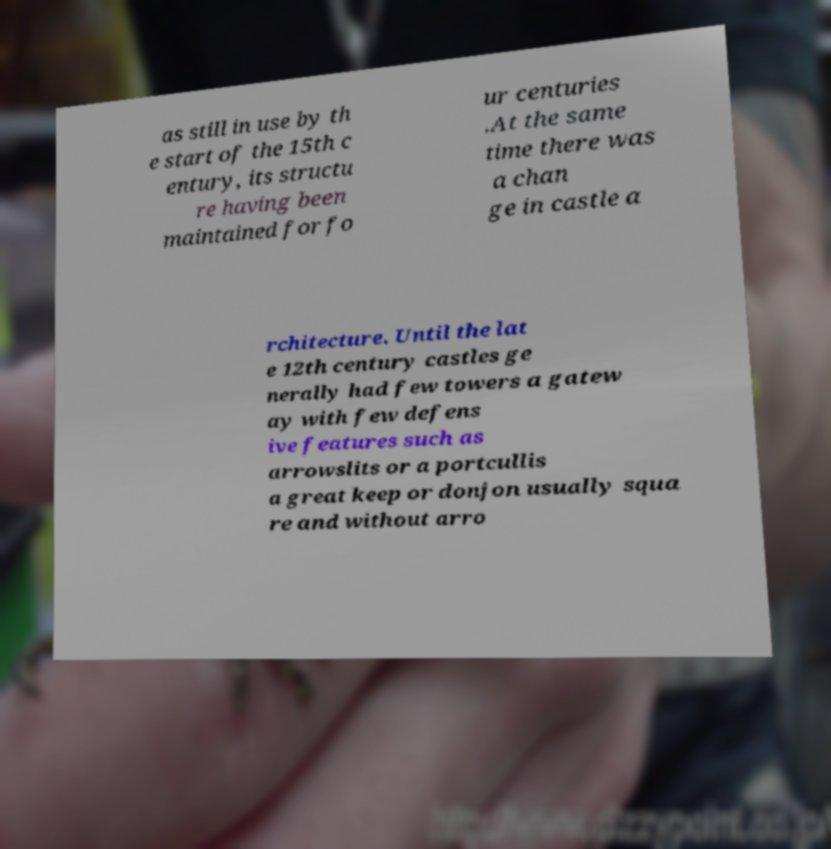For documentation purposes, I need the text within this image transcribed. Could you provide that? as still in use by th e start of the 15th c entury, its structu re having been maintained for fo ur centuries .At the same time there was a chan ge in castle a rchitecture. Until the lat e 12th century castles ge nerally had few towers a gatew ay with few defens ive features such as arrowslits or a portcullis a great keep or donjon usually squa re and without arro 